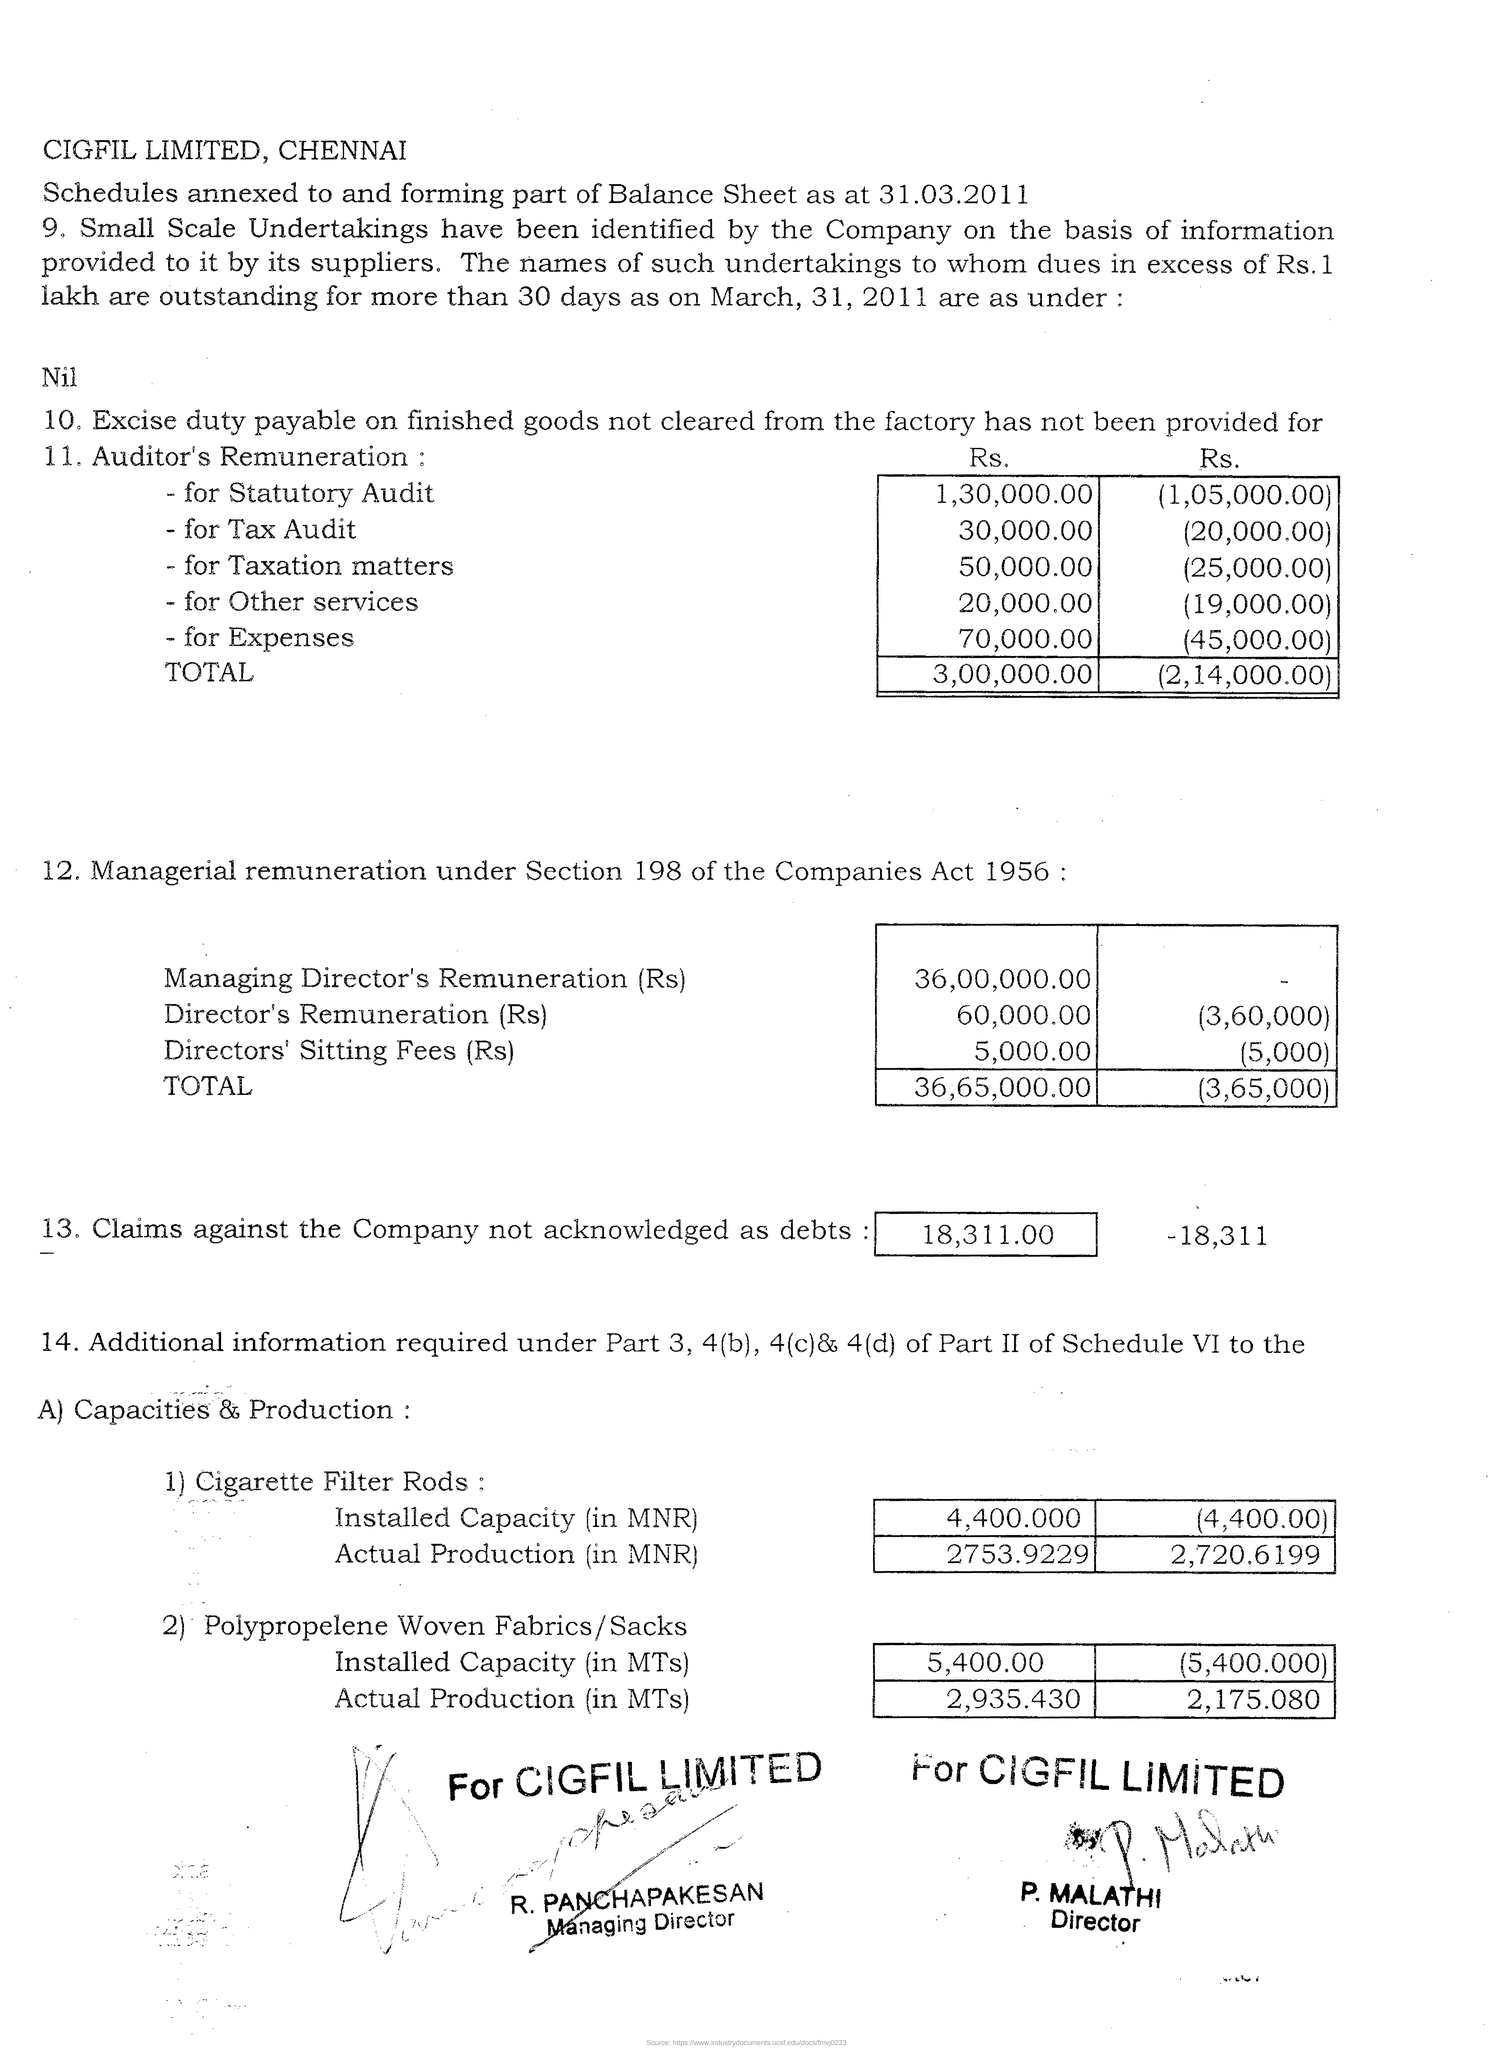What is the Company name and location given at the beginning of the document?
Offer a very short reply. CIGFIL LIMITED, CHENNAI. Mention the date at which Schedules annexed and partial Balance sheet formed?
Your answer should be compact. 31.03.2011. What is the total amount which has not been provided for Auditor's Remuneration based on first column of table 1?
Offer a very short reply. 3,00,000.00. How much is the Managing Director's Remuneration in Rs based on first column of table 2?
Offer a terse response. 36,00,000.00. What is the highest amount in first column of table 1 "Auditor's Remuneration" ?
Provide a succinct answer. 1,30,000.00. What is the minimum amount in the first column of second table "12. Managerial remuneration" ?
Offer a very short reply. 5,000.00. Who is the director of 'CIGFIL LIMITED' printed at the end of the document ?
Make the answer very short. P. MALATHI. 